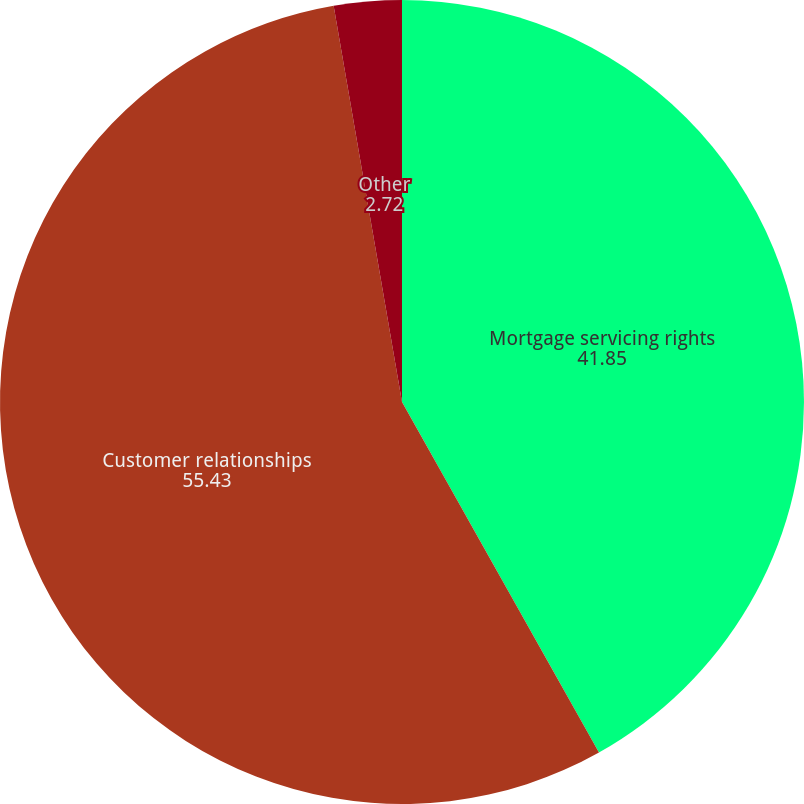Convert chart. <chart><loc_0><loc_0><loc_500><loc_500><pie_chart><fcel>Mortgage servicing rights<fcel>Customer relationships<fcel>Other<nl><fcel>41.85%<fcel>55.43%<fcel>2.72%<nl></chart> 